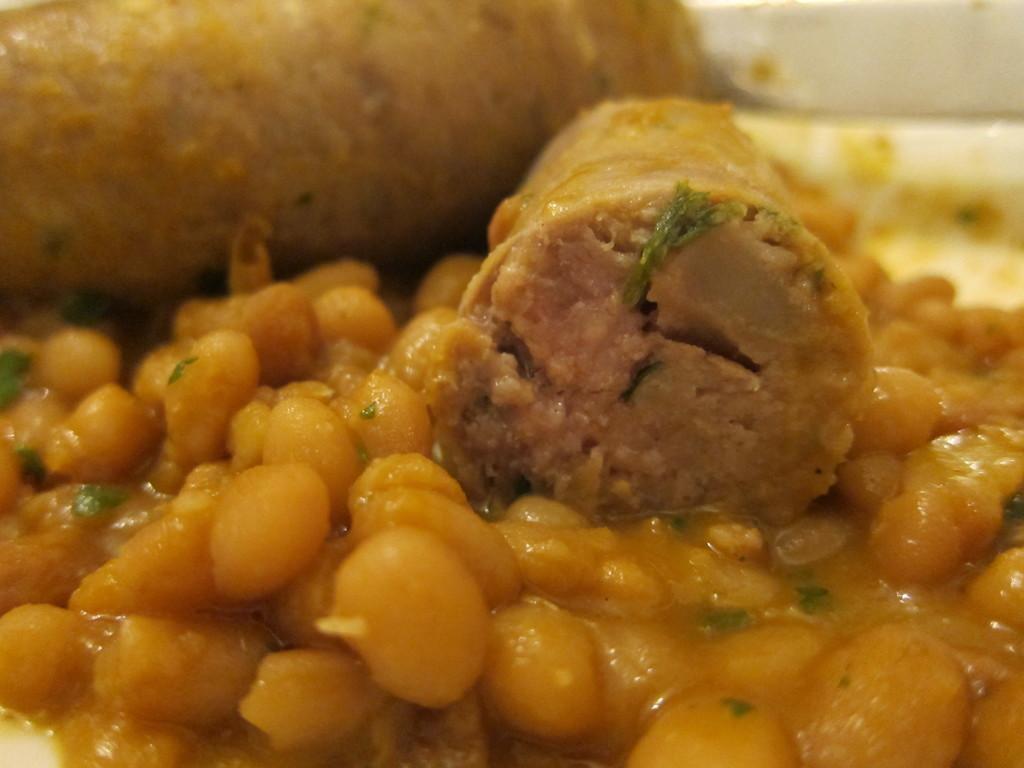In one or two sentences, can you explain what this image depicts? In this image I can see food which is lite yellow color in the plate and the plate is in white color. 